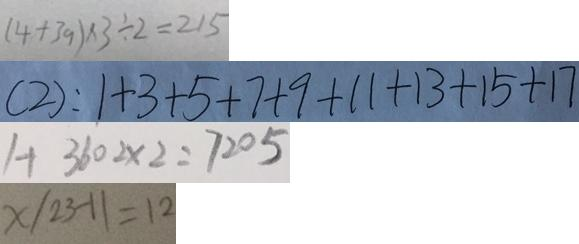<formula> <loc_0><loc_0><loc_500><loc_500>( 4 + 3 9 ) \times 3 \div 2 = 2 1 5 
 ( 2 ) : 1 + 3 + 5 + 7 + 9 + 1 1 + 1 3 + 1 5 + 1 7 
 1 + 3 6 0 2 \times 2 = 7 2 0 5 
 x / 2 3 - 1 1 = 1 2</formula> 